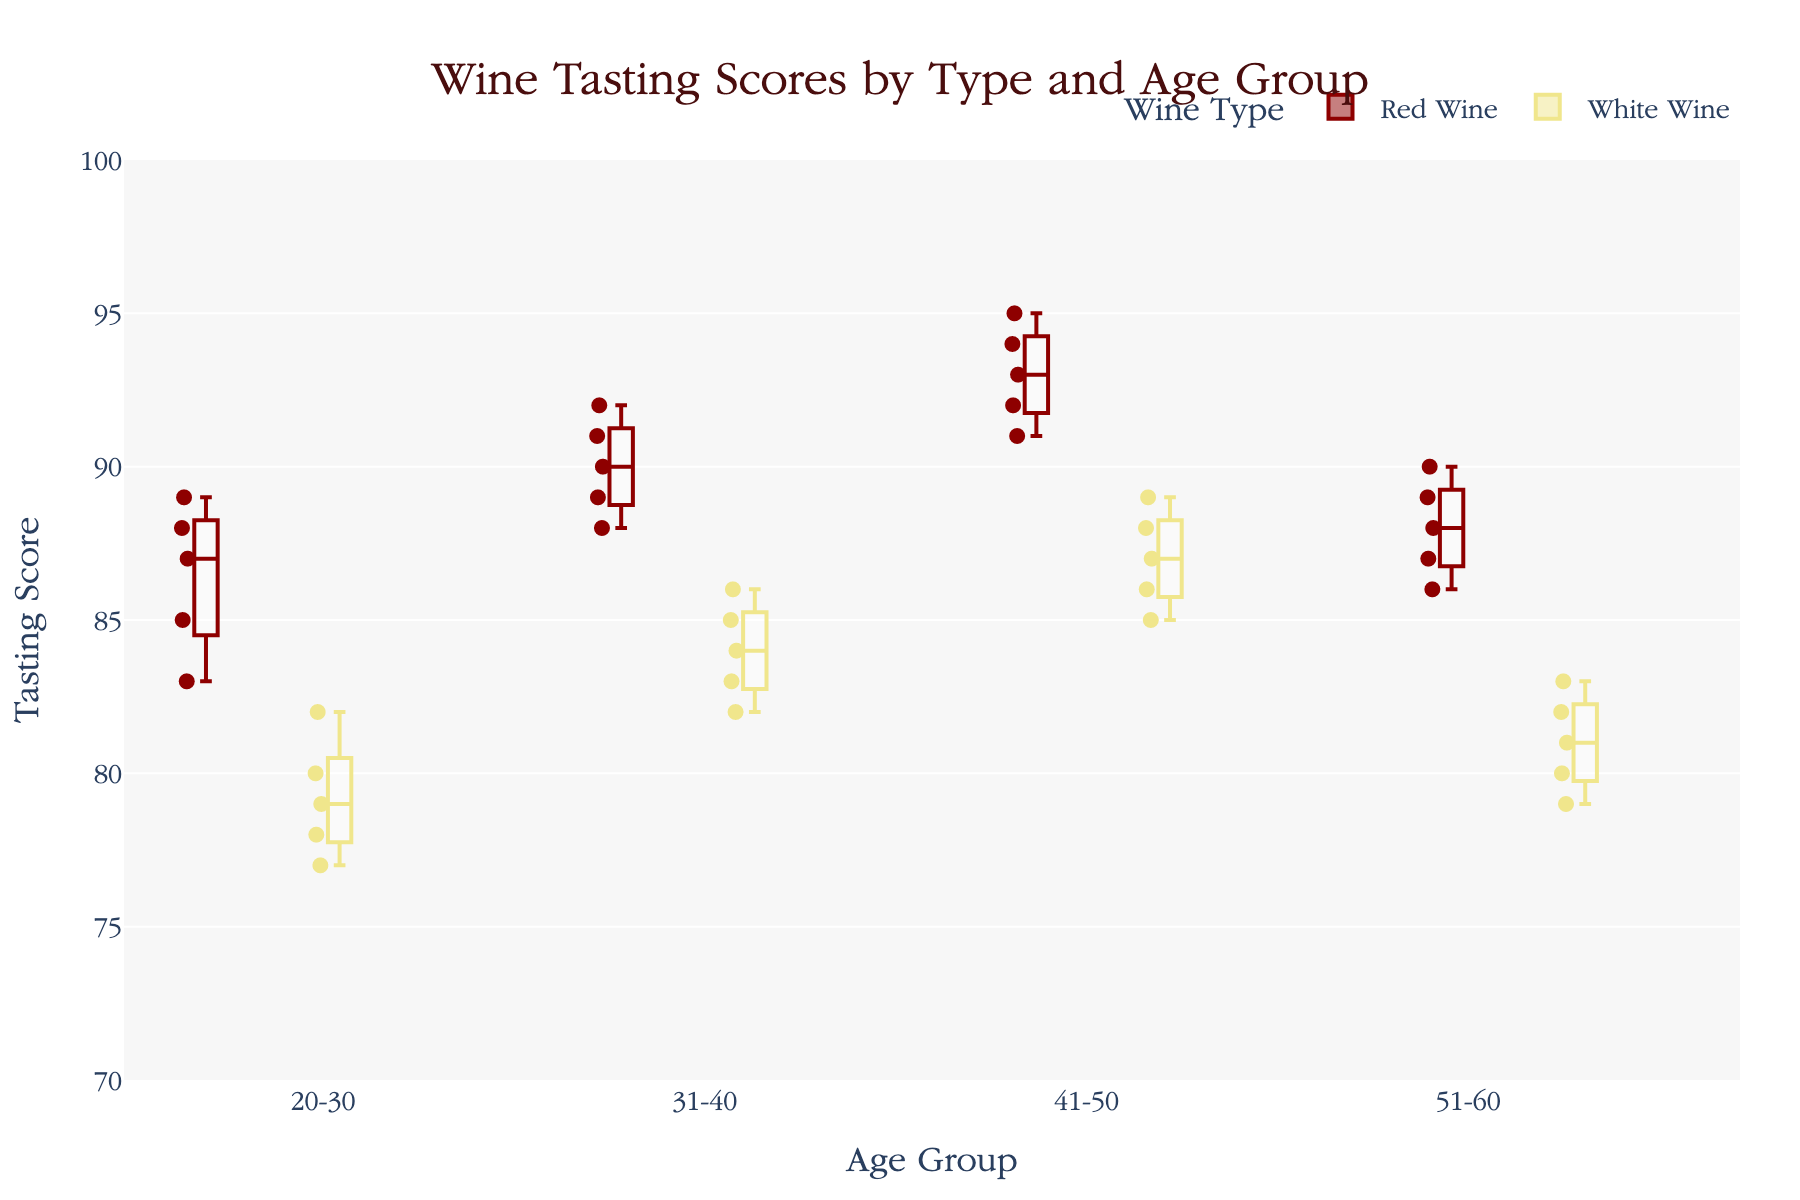What is the title of the plot? The title of the plot is usually displayed at the top. Here, it reads "Wine Tasting Scores by Type and Age Group".
Answer: Wine Tasting Scores by Type and Age Group What does the x-axis represent? The x-axis lists the taster age groups, which are "20-30", "31-40", "41-50", and "51-60" as indicated below each box plot group.
Answer: Age Group What wine type has the highest median score in the 41-50 age group? The red wine box plot for the 41-50 age group has a higher median score compared to the white wine box plot, as indicated by the position of the median line within the box.
Answer: Red Wine How do the tasting scores for red wine compare between the 20-30 and 51-60 age groups? The median and quartiles of the box plots show that the red wine scores for the 51-60 age group are slightly higher than those for the 20-30 age group, with the median of the 51-60 group around 88 and the 20-30 group around 87.
Answer: Slightly Higher What is the interquartile range (IQR) for white wine scores in the 31-40 age group? The IQR is the difference between the 75th percentile (upper quartile) and the 25th percentile (lower quartile) within the box. Here, the 75th percentile is approximately 86 and the 25th percentile is approximately 83. So, the IQR is 86 - 83 = 3.
Answer: 3 Which age group has the lowest overall score for white wine? By examining the position of the whiskers and outliers, the lowest score for white wine is observed in the 20-30 age group at a score of 77.
Answer: 20-30 In which age group is the red wine score more variable (has a larger spread)? The age group 20-30 red wine scores have a larger spread, evidenced by the wider range between the whiskers (83 to 89) compared to other age groups.
Answer: 20-30 Do any age groups have overlapping score ranges between red and white wines? Overlapping box plot whiskers indicate that for age groups 20-30, 31-40, 41-50, and 51-60, the score ranges of red wine and white wine do overlap, with intersecting whiskers and sometimes interquartile ranges.
Answer: Yes Comparing both wine types, which age group shows the smallest difference in median scores? The age group 31-40 shows the smallest difference between the median scores of red and white wines; red wine has a median around 90 and white wine around 84, so the difference is 6 points.
Answer: 31-40 